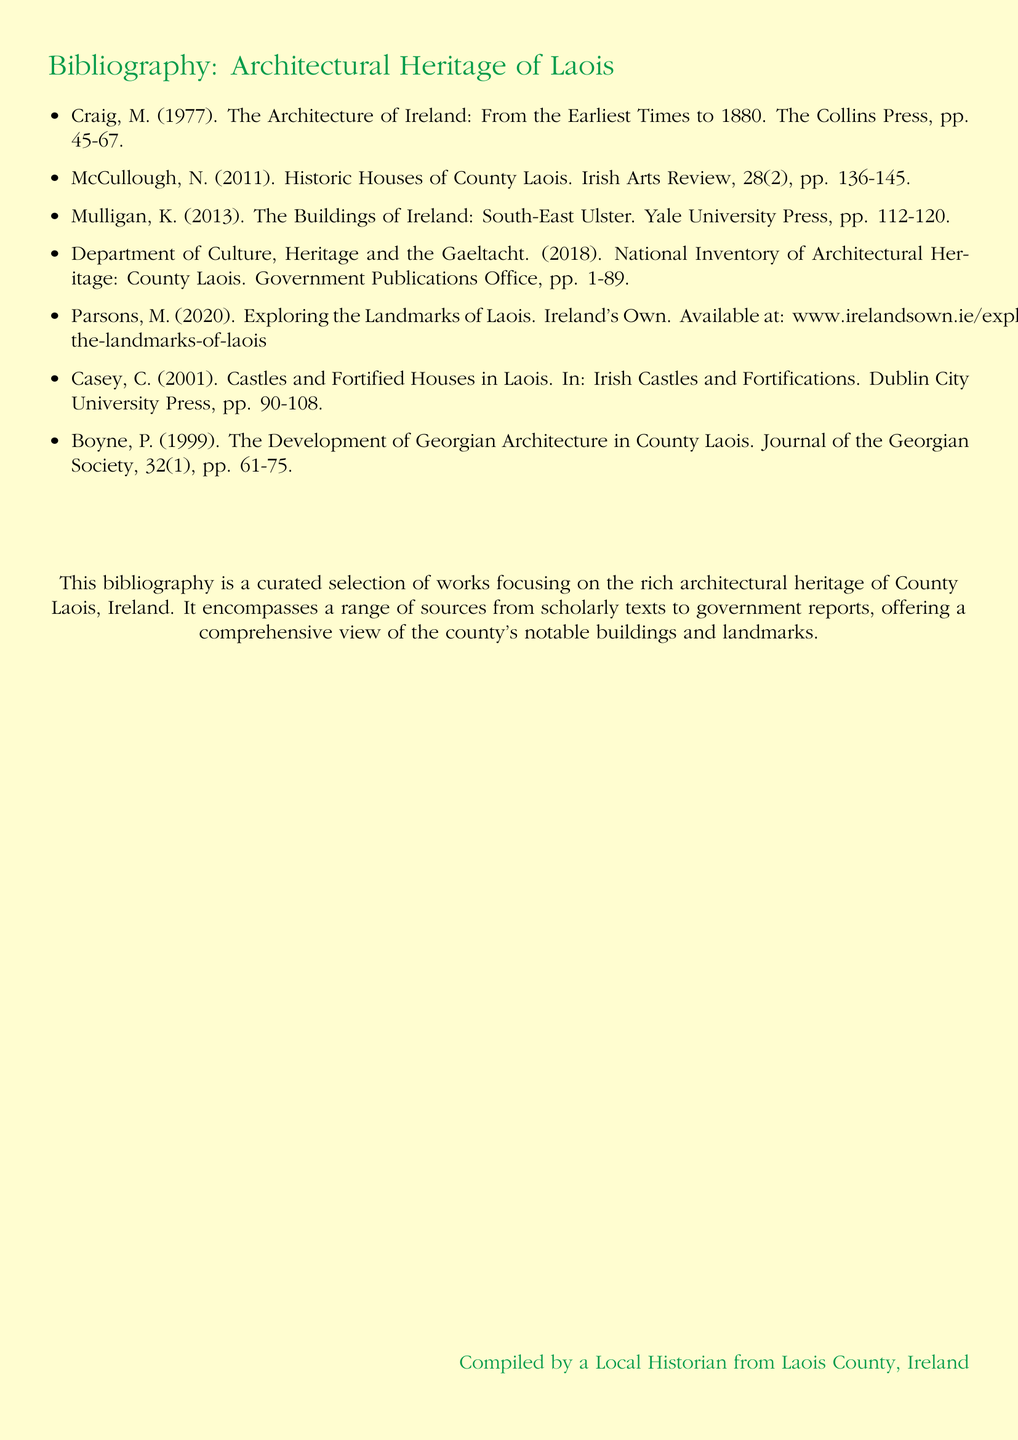what is the title of the document? The document is titled "Bibliography: Architectural Heritage of Laois".
Answer: Architectural Heritage of Laois who is the author of the first cited work? The first work listed in the bibliography is authored by M. Craig.
Answer: M. Craig in which year was the National Inventory of Architectural Heritage: County Laois published? The publication year for this work is 2018, as noted in the citation.
Answer: 2018 how many pages does the work by McCullough cover? The work authored by N. McCullough spans from pages 136 to 145, totaling 10 pages.
Answer: 10 which publisher produced the work on Georgian Architecture in County Laois? The work titled "The Development of Georgian Architecture in County Laois" is published by the Journal of the Georgian Society.
Answer: Journal of the Georgian Society who compiled this bibliography? The bibliography was compiled by a Local Historian from Laois County, Ireland, as stated at the end.
Answer: Local Historian from Laois County, Ireland what type of document is this? The format of the document is a bibliography, listing various sources related to architectural heritage.
Answer: bibliography how many works are listed in the bibliography? The total number of works cited in the bibliography is seven, as counted in the items listed.
Answer: seven 